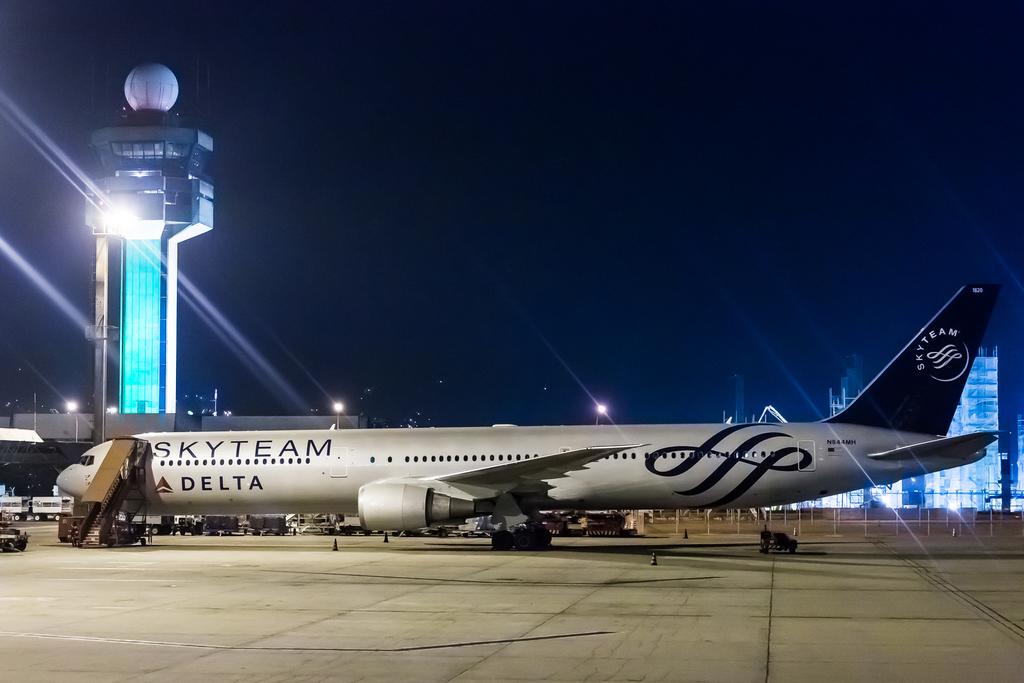Which airline is this?
Make the answer very short. Delta. What does it say on the tail?
Offer a terse response. Skyteam. 